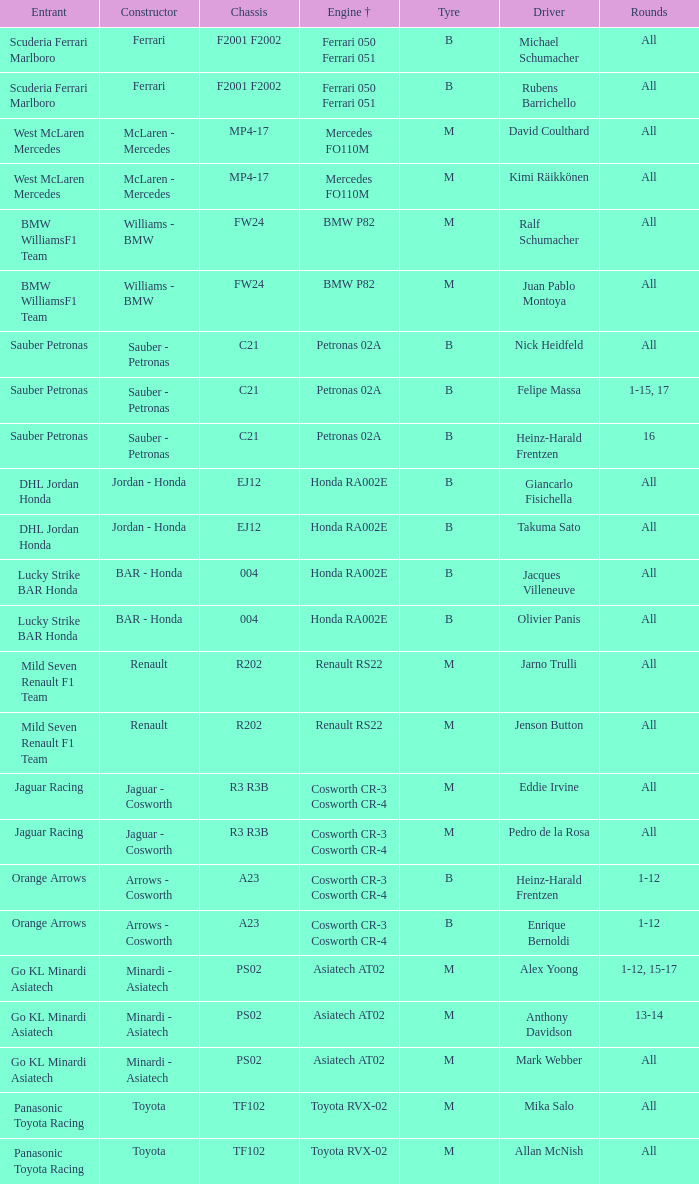When the engine is a mercedes fo110m, who is in charge of driving? David Coulthard, Kimi Räikkönen. 